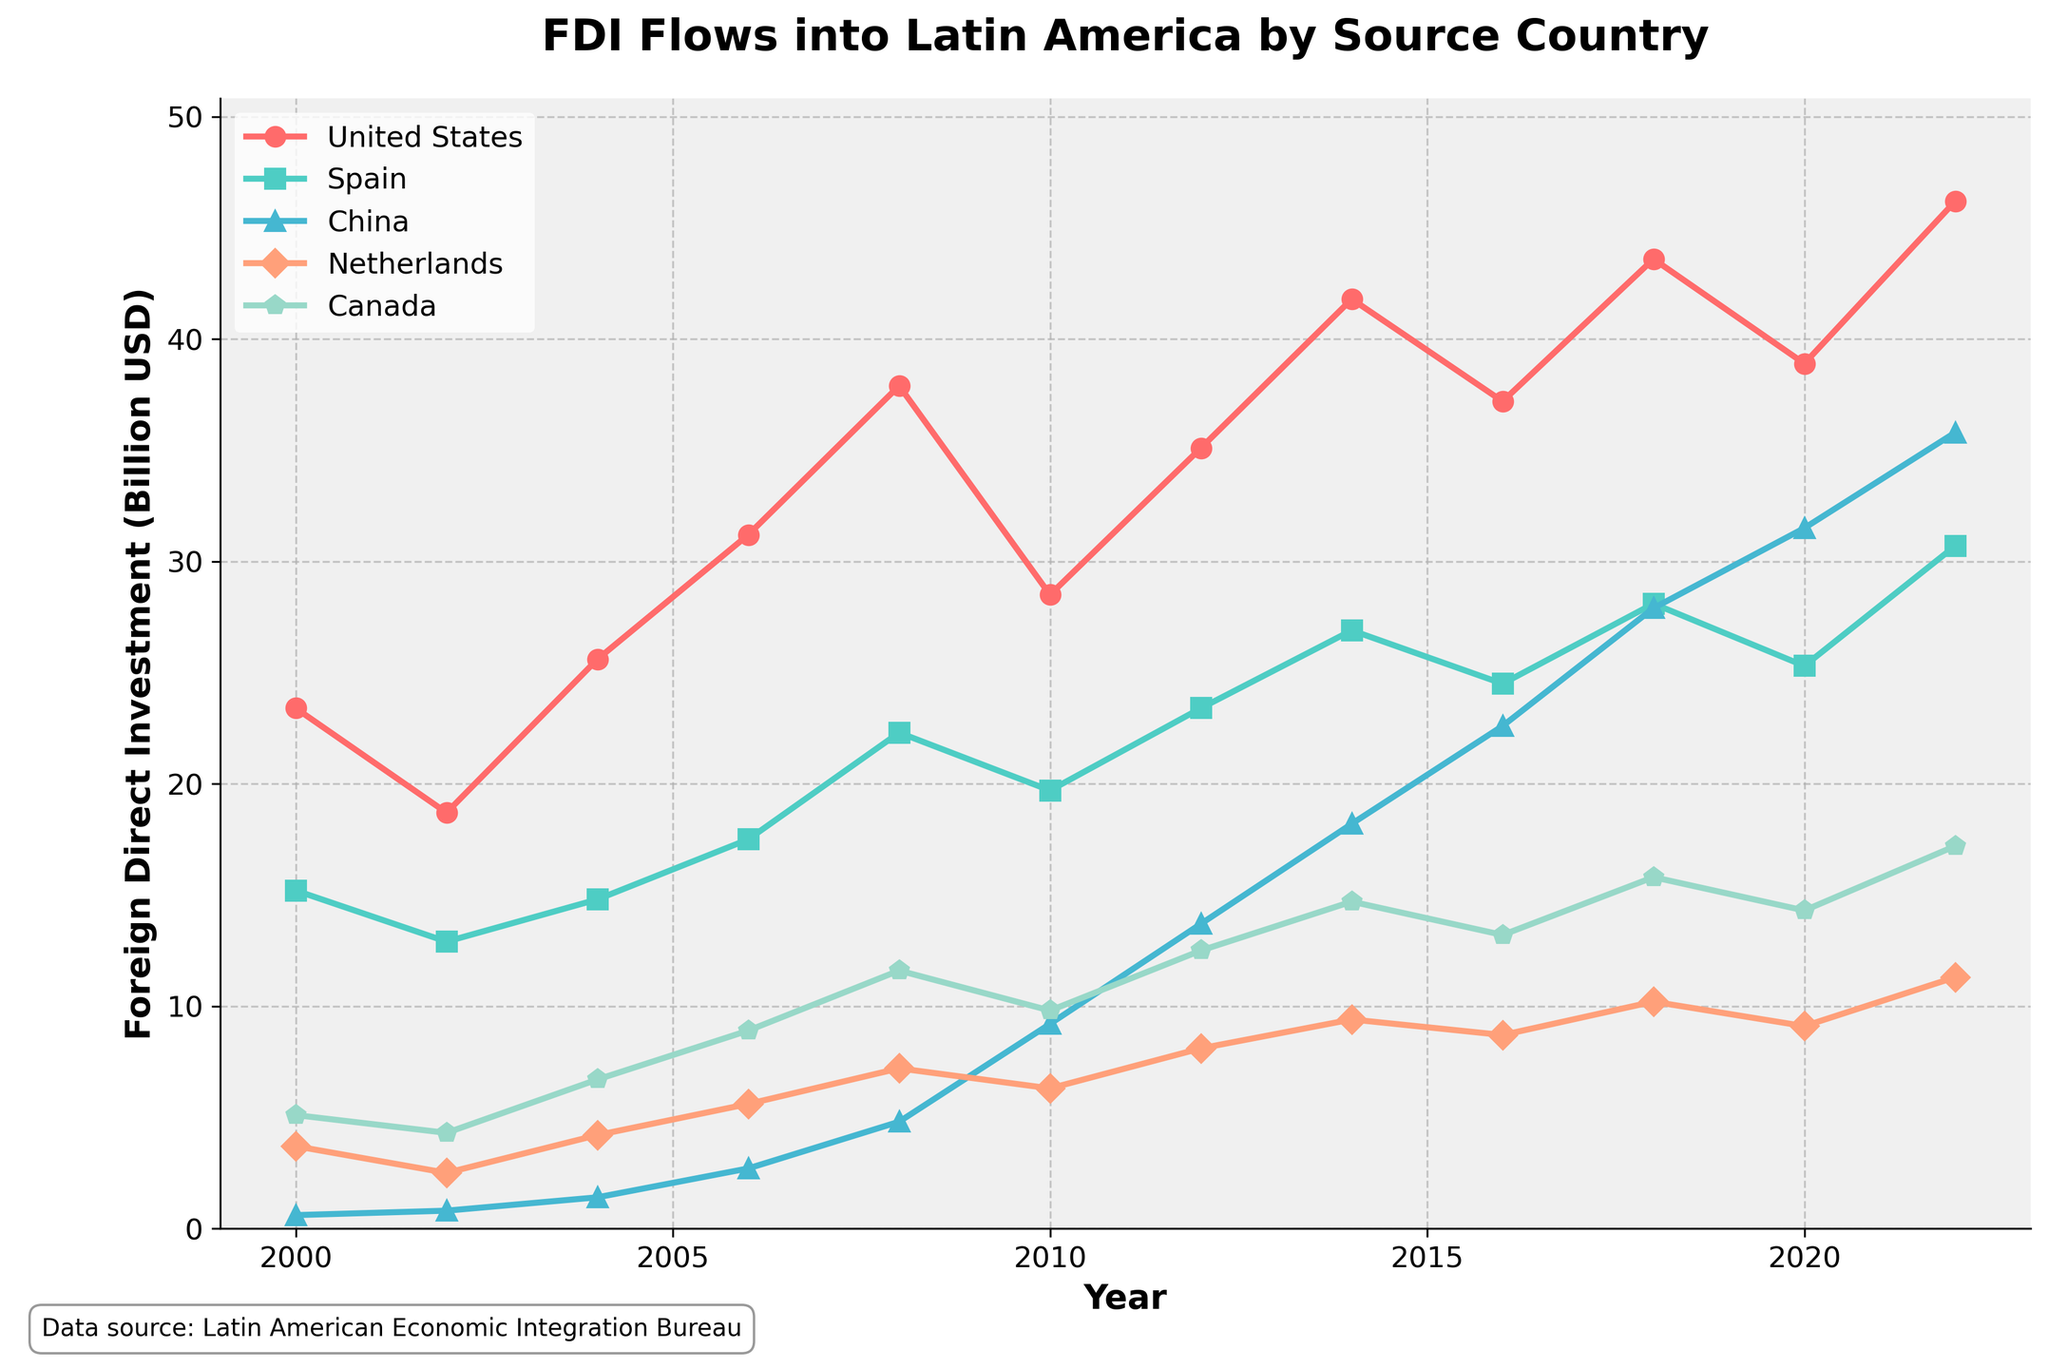What's the trend of FDI flows from the United States over the given period? The FDI flows from the United States show an overall increasing trend from 23.4 billion USD in 2000 to 46.2 billion USD in 2022, despite some fluctuations during the years.
Answer: Increasing Which country had the highest FDI flows into Latin America by the end of the period? By the end of the period (2022), the United States had the highest FDI flows into Latin America at 46.2 billion USD.
Answer: United States How do the FDI flows from China compare with those from Spain in 2022? In 2022, FDI flows from China were 35.8 billion USD, whereas from Spain were 30.7 billion USD. Therefore, China's FDI flows were higher than those from Spain by 5.1 billion USD.
Answer: China had higher FDI flows What is the average FDI flow from Canada over the years provided in the data? To calculate the average, sum up the FDI flows from Canada over the years and divide by the number of years: (5.1 + 4.3 + 6.7 + 8.9 + 11.6 + 9.8 + 12.5 + 14.7 + 13.2 + 15.8 + 14.3 + 17.2) / 12 = 11.225 billion USD.
Answer: 11.225 billion USD What is the difference between the FDI flows from the United States and the Netherlands in the year 2018? In 2018, the FDI flow from the United States was 43.6 billion USD, and from the Netherlands was 10.2 billion USD. The difference is 43.6 - 10.2 = 33.4 billion USD.
Answer: 33.4 billion USD Which country showed the most significant growth in FDI flows from 2000 to 2022? To find the most significant growth, calculate the change for each country between 2000 and 2022 and compare them. United States: 46.2 - 23.4 = 22.8, Spain: 30.7 - 15.2 = 15.5, China: 35.8 - 0.6 = 35.2, Netherlands: 11.3 - 3.7 = 7.6, Canada: 17.2 - 5.1 = 12.1. China showed the most significant growth of 35.2 billion USD.
Answer: China What can you infer about the visual representation of the FDI flows from the United States compared to Spain, in terms of color and markers used in the chart? The FDI line for the United States is represented in red with circular markers, while the FDI line for Spain is shown in green with square markers.
Answer: Red with circles for the US, Green with squares for Spain What is the sum of FDI flows from Japan and Germany in 2006? In 2006, the FDI flow from Japan was 5.7 billion USD, and from Germany was 4.1 billion USD. The sum of these flows is 5.7 + 4.1 = 9.8 billion USD.
Answer: 9.8 billion USD Which country had a decreasing trend in FDI flows from 2008 to 2010? By examining the trend lines, only the United States shows a decreasing trend in FDI flows, from 37.9 billion USD in 2008 to 28.5 billion USD in 2010.
Answer: United States 